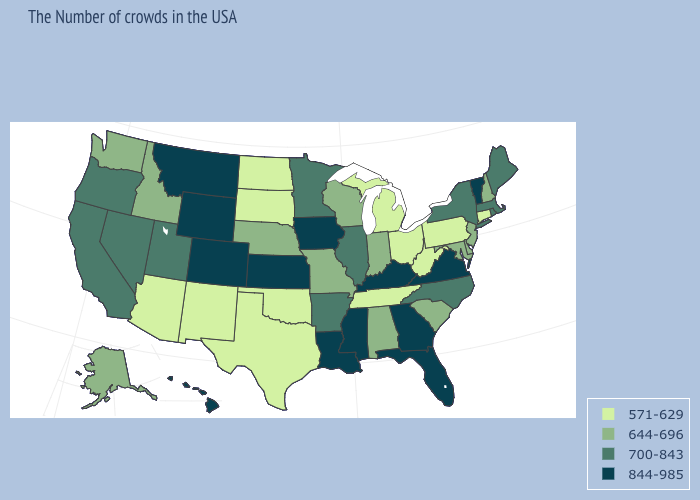Does Iowa have the highest value in the MidWest?
Answer briefly. Yes. What is the value of Washington?
Give a very brief answer. 644-696. Name the states that have a value in the range 644-696?
Write a very short answer. New Hampshire, New Jersey, Delaware, Maryland, South Carolina, Indiana, Alabama, Wisconsin, Missouri, Nebraska, Idaho, Washington, Alaska. Does New Jersey have the same value as Oklahoma?
Give a very brief answer. No. Does Illinois have the highest value in the USA?
Write a very short answer. No. What is the value of Ohio?
Keep it brief. 571-629. How many symbols are there in the legend?
Be succinct. 4. Among the states that border Utah , which have the highest value?
Give a very brief answer. Wyoming, Colorado. What is the highest value in states that border Alabama?
Concise answer only. 844-985. What is the value of Missouri?
Write a very short answer. 644-696. Name the states that have a value in the range 700-843?
Short answer required. Maine, Massachusetts, Rhode Island, New York, North Carolina, Illinois, Arkansas, Minnesota, Utah, Nevada, California, Oregon. Does New Mexico have the lowest value in the West?
Quick response, please. Yes. Does Nevada have the highest value in the West?
Quick response, please. No. What is the lowest value in the Northeast?
Write a very short answer. 571-629. What is the value of New Mexico?
Short answer required. 571-629. 